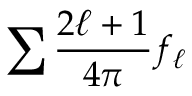<formula> <loc_0><loc_0><loc_500><loc_500>\sum \frac { 2 \ell + 1 } { 4 \pi } f _ { \ell }</formula> 